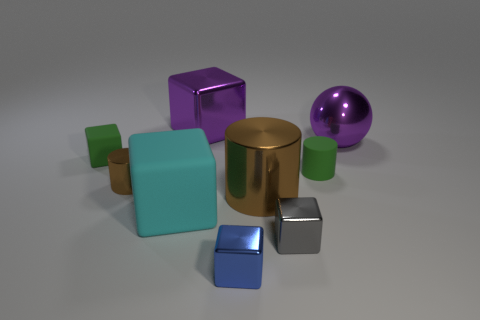Subtract all brown metallic cylinders. How many cylinders are left? 1 Subtract all gray cubes. How many cubes are left? 4 Subtract all balls. How many objects are left? 8 Subtract 2 blocks. How many blocks are left? 3 Add 5 rubber cubes. How many rubber cubes exist? 7 Subtract 0 gray balls. How many objects are left? 9 Subtract all green cylinders. Subtract all red cubes. How many cylinders are left? 2 Subtract all brown cylinders. How many cyan cubes are left? 1 Subtract all purple metallic objects. Subtract all big red matte things. How many objects are left? 7 Add 4 tiny green rubber blocks. How many tiny green rubber blocks are left? 5 